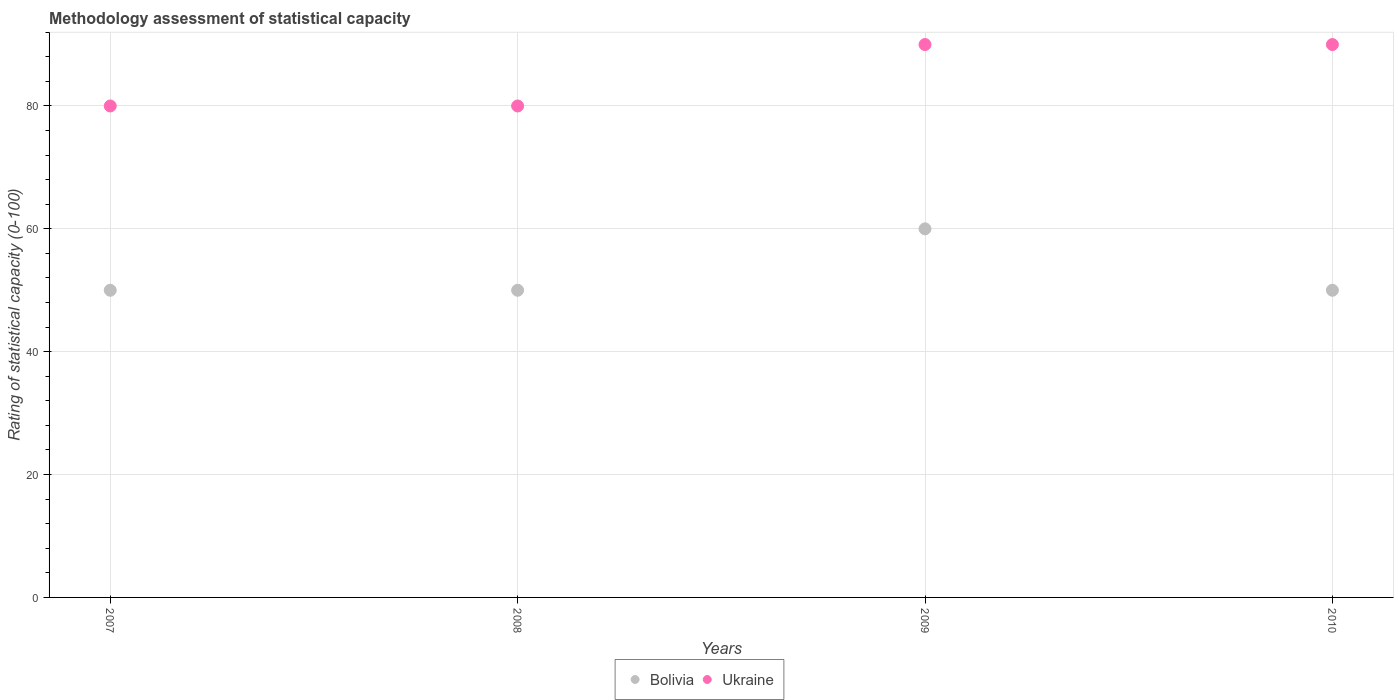How many different coloured dotlines are there?
Offer a terse response. 2. What is the rating of statistical capacity in Bolivia in 2010?
Your response must be concise. 50. Across all years, what is the maximum rating of statistical capacity in Bolivia?
Give a very brief answer. 60. Across all years, what is the minimum rating of statistical capacity in Bolivia?
Keep it short and to the point. 50. In which year was the rating of statistical capacity in Bolivia minimum?
Provide a short and direct response. 2007. What is the total rating of statistical capacity in Ukraine in the graph?
Make the answer very short. 340. What is the difference between the rating of statistical capacity in Bolivia in 2007 and that in 2008?
Ensure brevity in your answer.  0. What is the difference between the rating of statistical capacity in Ukraine in 2009 and the rating of statistical capacity in Bolivia in 2008?
Give a very brief answer. 40. In the year 2007, what is the difference between the rating of statistical capacity in Bolivia and rating of statistical capacity in Ukraine?
Provide a short and direct response. -30. In how many years, is the rating of statistical capacity in Bolivia greater than 48?
Offer a very short reply. 4. Is the difference between the rating of statistical capacity in Bolivia in 2008 and 2009 greater than the difference between the rating of statistical capacity in Ukraine in 2008 and 2009?
Your response must be concise. No. What is the difference between the highest and the second highest rating of statistical capacity in Ukraine?
Ensure brevity in your answer.  0. What is the difference between the highest and the lowest rating of statistical capacity in Bolivia?
Make the answer very short. 10. Is the sum of the rating of statistical capacity in Ukraine in 2007 and 2010 greater than the maximum rating of statistical capacity in Bolivia across all years?
Give a very brief answer. Yes. Does the rating of statistical capacity in Bolivia monotonically increase over the years?
Your answer should be very brief. No. Is the rating of statistical capacity in Ukraine strictly less than the rating of statistical capacity in Bolivia over the years?
Provide a succinct answer. No. What is the difference between two consecutive major ticks on the Y-axis?
Your response must be concise. 20. Are the values on the major ticks of Y-axis written in scientific E-notation?
Give a very brief answer. No. Where does the legend appear in the graph?
Your answer should be very brief. Bottom center. How many legend labels are there?
Offer a very short reply. 2. What is the title of the graph?
Your response must be concise. Methodology assessment of statistical capacity. What is the label or title of the Y-axis?
Your answer should be very brief. Rating of statistical capacity (0-100). What is the Rating of statistical capacity (0-100) in Bolivia in 2007?
Keep it short and to the point. 50. What is the Rating of statistical capacity (0-100) of Ukraine in 2007?
Provide a short and direct response. 80. What is the Rating of statistical capacity (0-100) of Bolivia in 2008?
Your answer should be compact. 50. What is the Rating of statistical capacity (0-100) of Bolivia in 2009?
Offer a terse response. 60. What is the Rating of statistical capacity (0-100) of Ukraine in 2009?
Offer a very short reply. 90. What is the Rating of statistical capacity (0-100) in Bolivia in 2010?
Give a very brief answer. 50. What is the Rating of statistical capacity (0-100) of Ukraine in 2010?
Make the answer very short. 90. Across all years, what is the maximum Rating of statistical capacity (0-100) in Bolivia?
Make the answer very short. 60. Across all years, what is the maximum Rating of statistical capacity (0-100) in Ukraine?
Your answer should be very brief. 90. What is the total Rating of statistical capacity (0-100) of Bolivia in the graph?
Give a very brief answer. 210. What is the total Rating of statistical capacity (0-100) of Ukraine in the graph?
Your answer should be very brief. 340. What is the difference between the Rating of statistical capacity (0-100) in Bolivia in 2007 and that in 2009?
Provide a succinct answer. -10. What is the difference between the Rating of statistical capacity (0-100) in Ukraine in 2008 and that in 2009?
Provide a short and direct response. -10. What is the difference between the Rating of statistical capacity (0-100) of Bolivia in 2009 and that in 2010?
Offer a terse response. 10. What is the average Rating of statistical capacity (0-100) of Bolivia per year?
Ensure brevity in your answer.  52.5. In the year 2007, what is the difference between the Rating of statistical capacity (0-100) in Bolivia and Rating of statistical capacity (0-100) in Ukraine?
Provide a succinct answer. -30. In the year 2008, what is the difference between the Rating of statistical capacity (0-100) of Bolivia and Rating of statistical capacity (0-100) of Ukraine?
Provide a short and direct response. -30. In the year 2009, what is the difference between the Rating of statistical capacity (0-100) in Bolivia and Rating of statistical capacity (0-100) in Ukraine?
Ensure brevity in your answer.  -30. What is the ratio of the Rating of statistical capacity (0-100) in Bolivia in 2007 to that in 2008?
Offer a terse response. 1. What is the ratio of the Rating of statistical capacity (0-100) of Ukraine in 2007 to that in 2008?
Give a very brief answer. 1. What is the ratio of the Rating of statistical capacity (0-100) in Bolivia in 2007 to that in 2009?
Keep it short and to the point. 0.83. What is the ratio of the Rating of statistical capacity (0-100) of Bolivia in 2007 to that in 2010?
Provide a short and direct response. 1. What is the ratio of the Rating of statistical capacity (0-100) of Bolivia in 2008 to that in 2009?
Offer a very short reply. 0.83. What is the ratio of the Rating of statistical capacity (0-100) in Bolivia in 2008 to that in 2010?
Ensure brevity in your answer.  1. What is the ratio of the Rating of statistical capacity (0-100) of Ukraine in 2008 to that in 2010?
Make the answer very short. 0.89. What is the ratio of the Rating of statistical capacity (0-100) of Ukraine in 2009 to that in 2010?
Ensure brevity in your answer.  1. What is the difference between the highest and the second highest Rating of statistical capacity (0-100) of Bolivia?
Provide a short and direct response. 10. What is the difference between the highest and the second highest Rating of statistical capacity (0-100) of Ukraine?
Your answer should be compact. 0. What is the difference between the highest and the lowest Rating of statistical capacity (0-100) of Bolivia?
Keep it short and to the point. 10. 